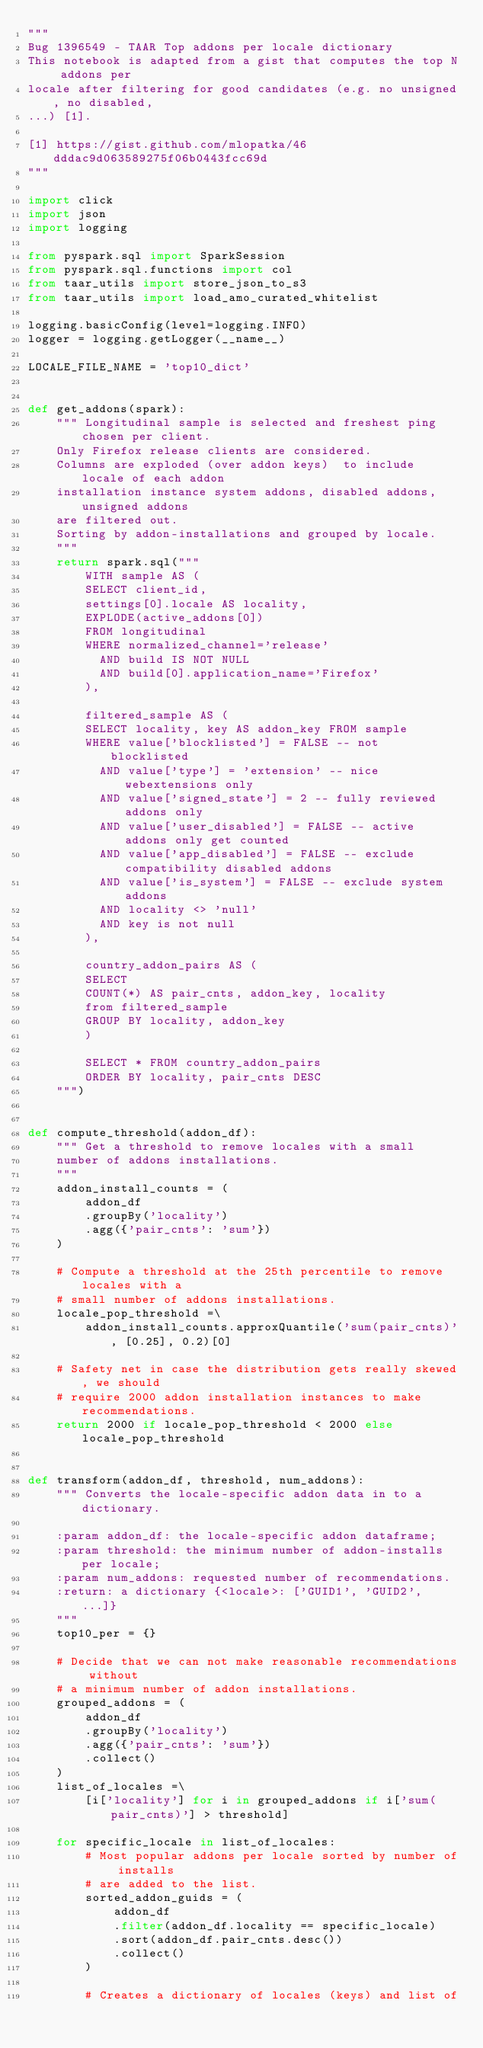Convert code to text. <code><loc_0><loc_0><loc_500><loc_500><_Python_>"""
Bug 1396549 - TAAR Top addons per locale dictionary
This notebook is adapted from a gist that computes the top N addons per
locale after filtering for good candidates (e.g. no unsigned, no disabled,
...) [1].

[1] https://gist.github.com/mlopatka/46dddac9d063589275f06b0443fcc69d
"""

import click
import json
import logging

from pyspark.sql import SparkSession
from pyspark.sql.functions import col
from taar_utils import store_json_to_s3
from taar_utils import load_amo_curated_whitelist

logging.basicConfig(level=logging.INFO)
logger = logging.getLogger(__name__)

LOCALE_FILE_NAME = 'top10_dict'


def get_addons(spark):
    """ Longitudinal sample is selected and freshest ping chosen per client.
    Only Firefox release clients are considered.
    Columns are exploded (over addon keys)  to include locale of each addon
    installation instance system addons, disabled addons, unsigned addons
    are filtered out.
    Sorting by addon-installations and grouped by locale.
    """
    return spark.sql("""
        WITH sample AS (
        SELECT client_id,
        settings[0].locale AS locality,
        EXPLODE(active_addons[0])
        FROM longitudinal
        WHERE normalized_channel='release'
          AND build IS NOT NULL
          AND build[0].application_name='Firefox'
        ),

        filtered_sample AS (
        SELECT locality, key AS addon_key FROM sample
        WHERE value['blocklisted'] = FALSE -- not blocklisted
          AND value['type'] = 'extension' -- nice webextensions only
          AND value['signed_state'] = 2 -- fully reviewed addons only
          AND value['user_disabled'] = FALSE -- active addons only get counted
          AND value['app_disabled'] = FALSE -- exclude compatibility disabled addons
          AND value['is_system'] = FALSE -- exclude system addons
          AND locality <> 'null'
          AND key is not null
        ),

        country_addon_pairs AS (
        SELECT
        COUNT(*) AS pair_cnts, addon_key, locality
        from filtered_sample
        GROUP BY locality, addon_key
        )

        SELECT * FROM country_addon_pairs
        ORDER BY locality, pair_cnts DESC
    """)


def compute_threshold(addon_df):
    """ Get a threshold to remove locales with a small
    number of addons installations.
    """
    addon_install_counts = (
        addon_df
        .groupBy('locality')
        .agg({'pair_cnts': 'sum'})
    )

    # Compute a threshold at the 25th percentile to remove locales with a
    # small number of addons installations.
    locale_pop_threshold =\
        addon_install_counts.approxQuantile('sum(pair_cnts)', [0.25], 0.2)[0]

    # Safety net in case the distribution gets really skewed, we should
    # require 2000 addon installation instances to make recommendations.
    return 2000 if locale_pop_threshold < 2000 else locale_pop_threshold


def transform(addon_df, threshold, num_addons):
    """ Converts the locale-specific addon data in to a dictionary.

    :param addon_df: the locale-specific addon dataframe;
    :param threshold: the minimum number of addon-installs per locale;
    :param num_addons: requested number of recommendations.
    :return: a dictionary {<locale>: ['GUID1', 'GUID2', ...]}
    """
    top10_per = {}

    # Decide that we can not make reasonable recommendations without
    # a minimum number of addon installations.
    grouped_addons = (
        addon_df
        .groupBy('locality')
        .agg({'pair_cnts': 'sum'})
        .collect()
    )
    list_of_locales =\
        [i['locality'] for i in grouped_addons if i['sum(pair_cnts)'] > threshold]

    for specific_locale in list_of_locales:
        # Most popular addons per locale sorted by number of installs
        # are added to the list.
        sorted_addon_guids = (
            addon_df
            .filter(addon_df.locality == specific_locale)
            .sort(addon_df.pair_cnts.desc())
            .collect()
        )

        # Creates a dictionary of locales (keys) and list of</code> 